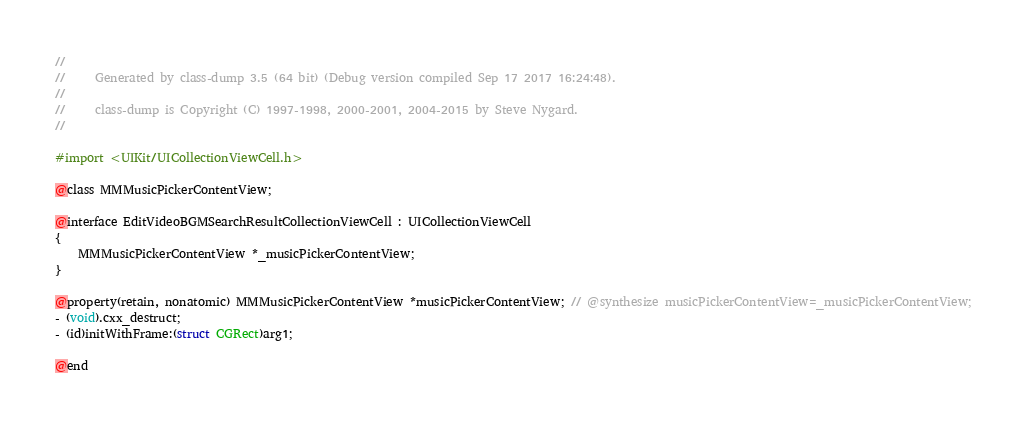<code> <loc_0><loc_0><loc_500><loc_500><_C_>//
//     Generated by class-dump 3.5 (64 bit) (Debug version compiled Sep 17 2017 16:24:48).
//
//     class-dump is Copyright (C) 1997-1998, 2000-2001, 2004-2015 by Steve Nygard.
//

#import <UIKit/UICollectionViewCell.h>

@class MMMusicPickerContentView;

@interface EditVideoBGMSearchResultCollectionViewCell : UICollectionViewCell
{
    MMMusicPickerContentView *_musicPickerContentView;
}

@property(retain, nonatomic) MMMusicPickerContentView *musicPickerContentView; // @synthesize musicPickerContentView=_musicPickerContentView;
- (void).cxx_destruct;
- (id)initWithFrame:(struct CGRect)arg1;

@end

</code> 